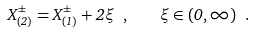Convert formula to latex. <formula><loc_0><loc_0><loc_500><loc_500>X ^ { \pm } _ { ( 2 ) } = X ^ { \pm } _ { ( 1 ) } + 2 \xi \ , \quad \xi \in ( 0 , \infty ) \ .</formula> 